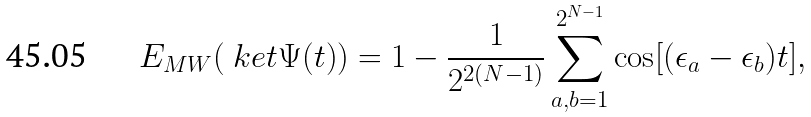<formula> <loc_0><loc_0><loc_500><loc_500>E _ { M W } ( \ k e t { \Psi ( t ) } ) = 1 - \frac { 1 } { 2 ^ { 2 ( N - 1 ) } } \sum _ { a , b = 1 } ^ { 2 ^ { N - 1 } } \cos [ ( \epsilon _ { a } - \epsilon _ { b } ) t ] ,</formula> 